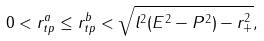Convert formula to latex. <formula><loc_0><loc_0><loc_500><loc_500>0 < r _ { t p } ^ { a } \leq r _ { t p } ^ { b } < \sqrt { l ^ { 2 } ( E ^ { 2 } - P ^ { 2 } ) - r _ { + } ^ { 2 } } ,</formula> 